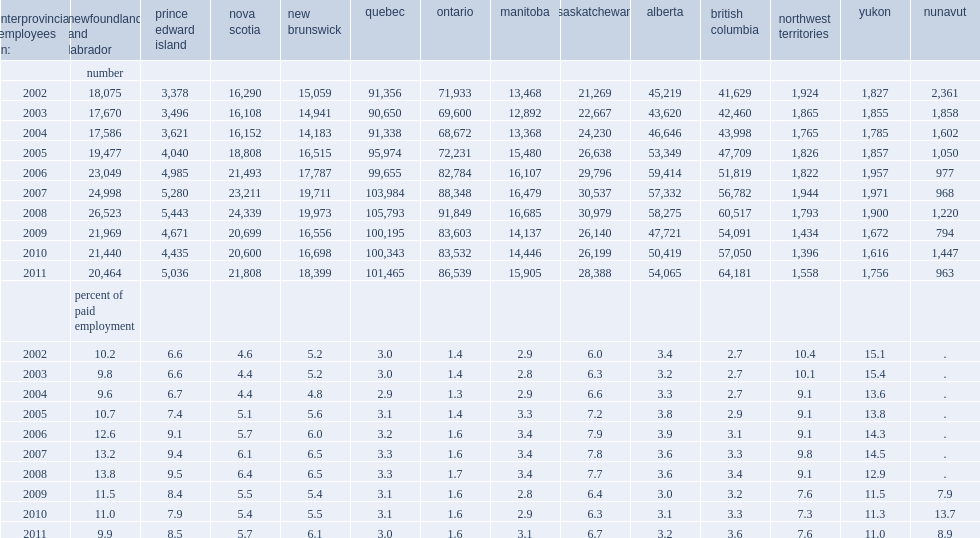In which year of the 2002 to 2011 periode do interprovincial employees who live in newfoundland and labrador represent at least 10% of the paid workforce of these jurisdictions? 2002.0 2005.0 2006.0 2007.0 2008.0 2009.0 2010.0. In which year of the 2002 to 2011 periode do interprovincial employees who live in yukon represent at least 10% of the paid workforce of these jurisdictions? 2002.0 2003.0 2004.0 2005.0 2006.0 2007.0 2008.0 2009.0 2010.0 2011.0. What is the maximum percentage of the paid workforce of that province of interprovincial employees residing in ontario representing? 1.7. 